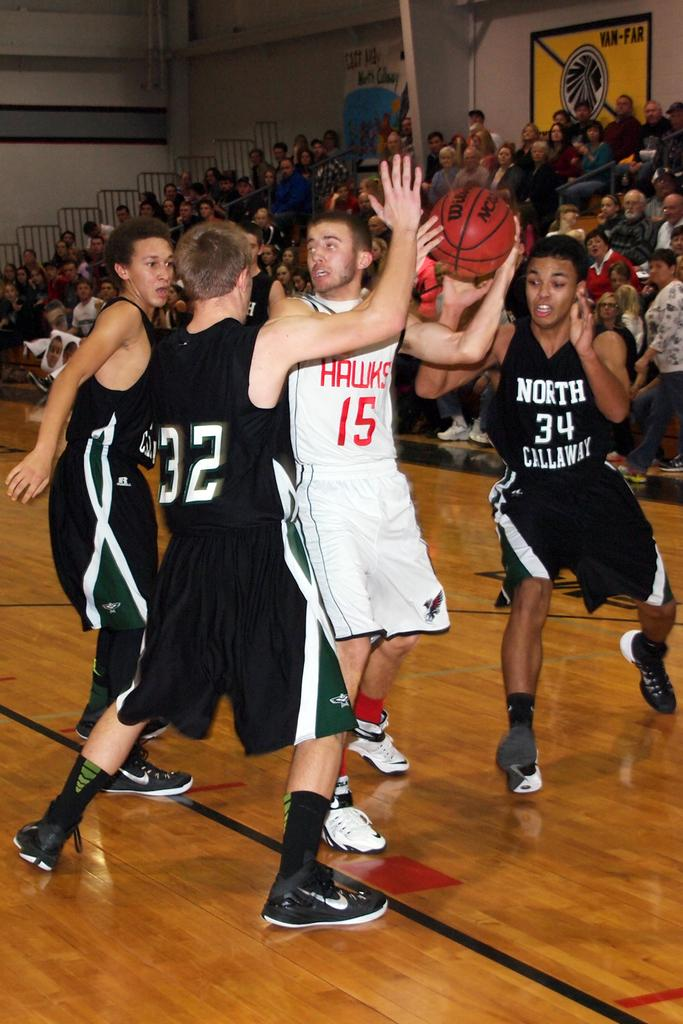<image>
Summarize the visual content of the image. a player that has a basketball in their hand and the number 15 